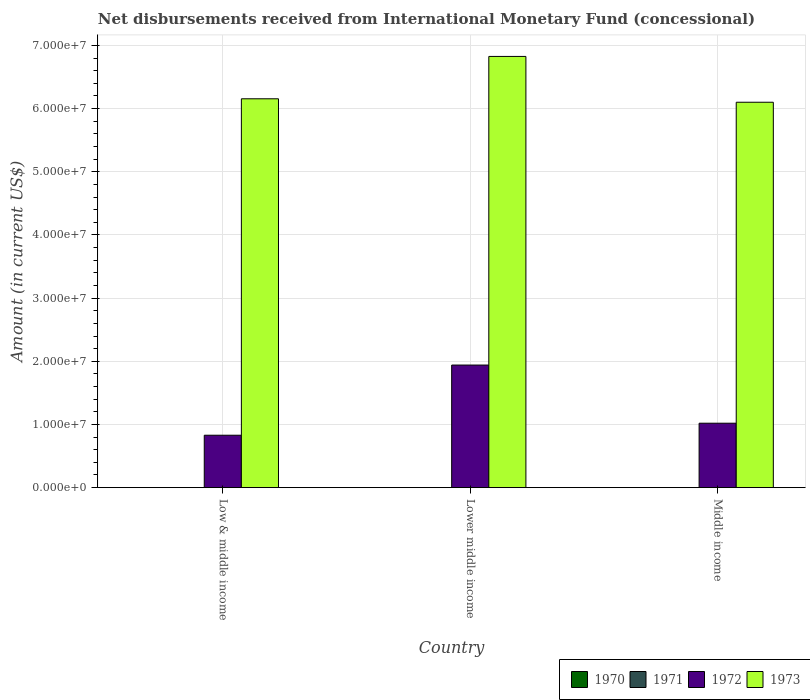How many different coloured bars are there?
Keep it short and to the point. 2. Are the number of bars per tick equal to the number of legend labels?
Offer a very short reply. No. Are the number of bars on each tick of the X-axis equal?
Offer a very short reply. Yes. How many bars are there on the 3rd tick from the right?
Keep it short and to the point. 2. What is the label of the 3rd group of bars from the left?
Your answer should be very brief. Middle income. What is the amount of disbursements received from International Monetary Fund in 1973 in Low & middle income?
Provide a short and direct response. 6.16e+07. Across all countries, what is the maximum amount of disbursements received from International Monetary Fund in 1972?
Your response must be concise. 1.94e+07. Across all countries, what is the minimum amount of disbursements received from International Monetary Fund in 1972?
Offer a terse response. 8.30e+06. In which country was the amount of disbursements received from International Monetary Fund in 1972 maximum?
Give a very brief answer. Lower middle income. What is the total amount of disbursements received from International Monetary Fund in 1972 in the graph?
Your answer should be compact. 3.79e+07. What is the difference between the amount of disbursements received from International Monetary Fund in 1972 in Low & middle income and that in Middle income?
Your answer should be compact. -1.90e+06. What is the difference between the amount of disbursements received from International Monetary Fund in 1970 in Low & middle income and the amount of disbursements received from International Monetary Fund in 1972 in Middle income?
Offer a very short reply. -1.02e+07. What is the difference between the amount of disbursements received from International Monetary Fund of/in 1972 and amount of disbursements received from International Monetary Fund of/in 1973 in Middle income?
Your answer should be very brief. -5.08e+07. In how many countries, is the amount of disbursements received from International Monetary Fund in 1970 greater than 10000000 US$?
Make the answer very short. 0. What is the ratio of the amount of disbursements received from International Monetary Fund in 1972 in Lower middle income to that in Middle income?
Offer a terse response. 1.9. What is the difference between the highest and the second highest amount of disbursements received from International Monetary Fund in 1973?
Offer a terse response. -7.25e+06. What is the difference between the highest and the lowest amount of disbursements received from International Monetary Fund in 1972?
Your answer should be compact. 1.11e+07. In how many countries, is the amount of disbursements received from International Monetary Fund in 1970 greater than the average amount of disbursements received from International Monetary Fund in 1970 taken over all countries?
Give a very brief answer. 0. Is it the case that in every country, the sum of the amount of disbursements received from International Monetary Fund in 1973 and amount of disbursements received from International Monetary Fund in 1971 is greater than the sum of amount of disbursements received from International Monetary Fund in 1972 and amount of disbursements received from International Monetary Fund in 1970?
Give a very brief answer. No. Is it the case that in every country, the sum of the amount of disbursements received from International Monetary Fund in 1970 and amount of disbursements received from International Monetary Fund in 1972 is greater than the amount of disbursements received from International Monetary Fund in 1973?
Your answer should be compact. No. How many countries are there in the graph?
Give a very brief answer. 3. What is the difference between two consecutive major ticks on the Y-axis?
Your answer should be very brief. 1.00e+07. Are the values on the major ticks of Y-axis written in scientific E-notation?
Your answer should be compact. Yes. Does the graph contain grids?
Keep it short and to the point. Yes. How are the legend labels stacked?
Your response must be concise. Horizontal. What is the title of the graph?
Make the answer very short. Net disbursements received from International Monetary Fund (concessional). Does "1976" appear as one of the legend labels in the graph?
Your response must be concise. No. What is the label or title of the X-axis?
Give a very brief answer. Country. What is the label or title of the Y-axis?
Your answer should be very brief. Amount (in current US$). What is the Amount (in current US$) of 1970 in Low & middle income?
Make the answer very short. 0. What is the Amount (in current US$) of 1971 in Low & middle income?
Give a very brief answer. 0. What is the Amount (in current US$) of 1972 in Low & middle income?
Offer a terse response. 8.30e+06. What is the Amount (in current US$) in 1973 in Low & middle income?
Ensure brevity in your answer.  6.16e+07. What is the Amount (in current US$) of 1970 in Lower middle income?
Provide a short and direct response. 0. What is the Amount (in current US$) in 1972 in Lower middle income?
Offer a very short reply. 1.94e+07. What is the Amount (in current US$) in 1973 in Lower middle income?
Provide a short and direct response. 6.83e+07. What is the Amount (in current US$) of 1970 in Middle income?
Make the answer very short. 0. What is the Amount (in current US$) in 1972 in Middle income?
Provide a succinct answer. 1.02e+07. What is the Amount (in current US$) of 1973 in Middle income?
Make the answer very short. 6.10e+07. Across all countries, what is the maximum Amount (in current US$) of 1972?
Provide a succinct answer. 1.94e+07. Across all countries, what is the maximum Amount (in current US$) of 1973?
Provide a succinct answer. 6.83e+07. Across all countries, what is the minimum Amount (in current US$) in 1972?
Make the answer very short. 8.30e+06. Across all countries, what is the minimum Amount (in current US$) in 1973?
Your response must be concise. 6.10e+07. What is the total Amount (in current US$) in 1970 in the graph?
Your answer should be very brief. 0. What is the total Amount (in current US$) in 1972 in the graph?
Make the answer very short. 3.79e+07. What is the total Amount (in current US$) in 1973 in the graph?
Give a very brief answer. 1.91e+08. What is the difference between the Amount (in current US$) of 1972 in Low & middle income and that in Lower middle income?
Offer a very short reply. -1.11e+07. What is the difference between the Amount (in current US$) of 1973 in Low & middle income and that in Lower middle income?
Provide a succinct answer. -6.70e+06. What is the difference between the Amount (in current US$) of 1972 in Low & middle income and that in Middle income?
Provide a succinct answer. -1.90e+06. What is the difference between the Amount (in current US$) of 1973 in Low & middle income and that in Middle income?
Your response must be concise. 5.46e+05. What is the difference between the Amount (in current US$) in 1972 in Lower middle income and that in Middle income?
Offer a terse response. 9.21e+06. What is the difference between the Amount (in current US$) of 1973 in Lower middle income and that in Middle income?
Offer a terse response. 7.25e+06. What is the difference between the Amount (in current US$) of 1972 in Low & middle income and the Amount (in current US$) of 1973 in Lower middle income?
Offer a very short reply. -6.00e+07. What is the difference between the Amount (in current US$) of 1972 in Low & middle income and the Amount (in current US$) of 1973 in Middle income?
Your answer should be compact. -5.27e+07. What is the difference between the Amount (in current US$) in 1972 in Lower middle income and the Amount (in current US$) in 1973 in Middle income?
Provide a succinct answer. -4.16e+07. What is the average Amount (in current US$) of 1970 per country?
Offer a very short reply. 0. What is the average Amount (in current US$) in 1971 per country?
Offer a terse response. 0. What is the average Amount (in current US$) of 1972 per country?
Offer a very short reply. 1.26e+07. What is the average Amount (in current US$) of 1973 per country?
Ensure brevity in your answer.  6.36e+07. What is the difference between the Amount (in current US$) in 1972 and Amount (in current US$) in 1973 in Low & middle income?
Offer a very short reply. -5.33e+07. What is the difference between the Amount (in current US$) in 1972 and Amount (in current US$) in 1973 in Lower middle income?
Your response must be concise. -4.89e+07. What is the difference between the Amount (in current US$) in 1972 and Amount (in current US$) in 1973 in Middle income?
Give a very brief answer. -5.08e+07. What is the ratio of the Amount (in current US$) in 1972 in Low & middle income to that in Lower middle income?
Give a very brief answer. 0.43. What is the ratio of the Amount (in current US$) in 1973 in Low & middle income to that in Lower middle income?
Provide a succinct answer. 0.9. What is the ratio of the Amount (in current US$) in 1972 in Low & middle income to that in Middle income?
Your response must be concise. 0.81. What is the ratio of the Amount (in current US$) of 1972 in Lower middle income to that in Middle income?
Provide a succinct answer. 1.9. What is the ratio of the Amount (in current US$) in 1973 in Lower middle income to that in Middle income?
Offer a very short reply. 1.12. What is the difference between the highest and the second highest Amount (in current US$) in 1972?
Your answer should be compact. 9.21e+06. What is the difference between the highest and the second highest Amount (in current US$) of 1973?
Offer a very short reply. 6.70e+06. What is the difference between the highest and the lowest Amount (in current US$) of 1972?
Ensure brevity in your answer.  1.11e+07. What is the difference between the highest and the lowest Amount (in current US$) in 1973?
Give a very brief answer. 7.25e+06. 